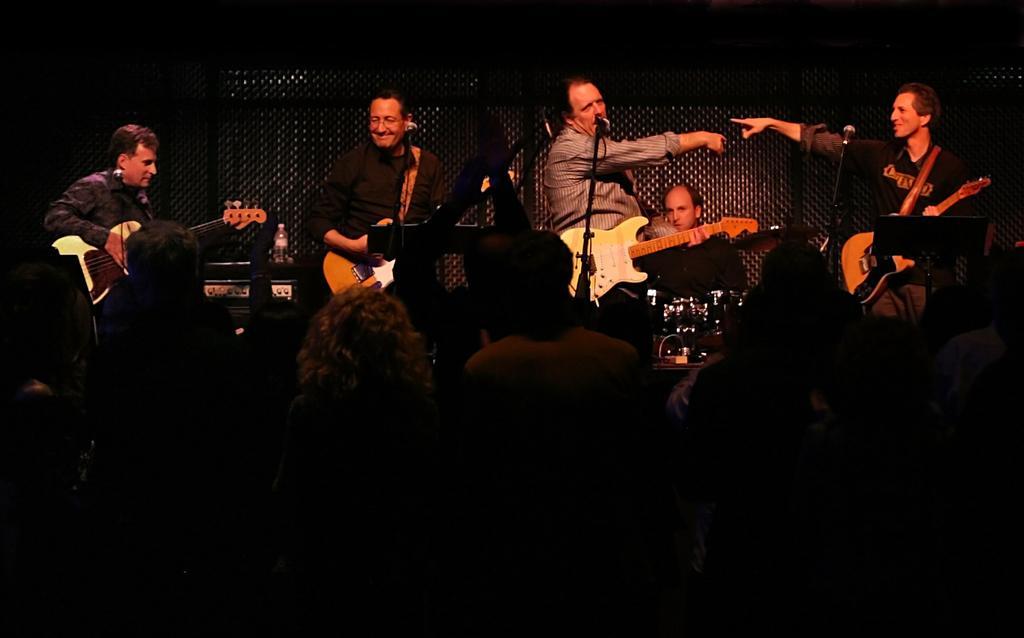Can you describe this image briefly? In this picture we can see few men playing some musical instruments. This is a mike. Here we can see audience. This is a water bottle on a device. 